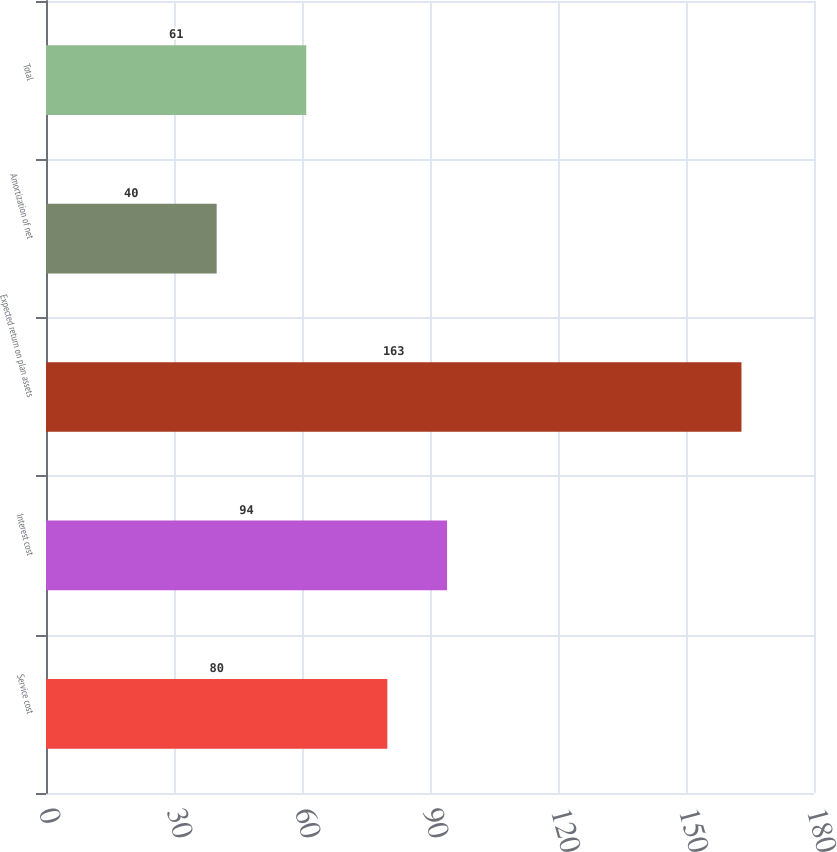<chart> <loc_0><loc_0><loc_500><loc_500><bar_chart><fcel>Service cost<fcel>Interest cost<fcel>Expected return on plan assets<fcel>Amortization of net<fcel>Total<nl><fcel>80<fcel>94<fcel>163<fcel>40<fcel>61<nl></chart> 